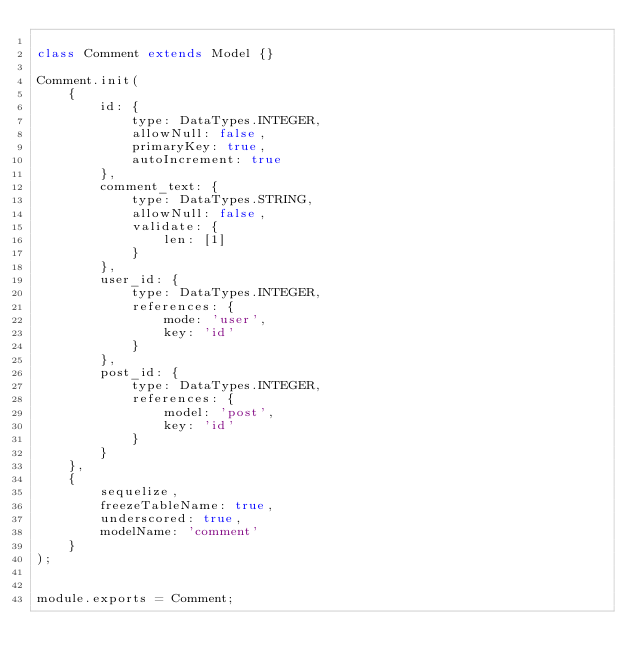<code> <loc_0><loc_0><loc_500><loc_500><_JavaScript_>
class Comment extends Model {}

Comment.init(
    {
        id: {
            type: DataTypes.INTEGER,
            allowNull: false,
            primaryKey: true,
            autoIncrement: true
        },
        comment_text: {
            type: DataTypes.STRING,
            allowNull: false,
            validate: {
                len: [1]
            }
        },
        user_id: {
            type: DataTypes.INTEGER,
            references: {
                mode: 'user',
                key: 'id'
            }
        },
        post_id: {
            type: DataTypes.INTEGER,
            references: {
                model: 'post',
                key: 'id'
            }
        }
    },
    {
        sequelize,
        freezeTableName: true,
        underscored: true,
        modelName: 'comment'
    }
);


module.exports = Comment;
</code> 